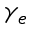<formula> <loc_0><loc_0><loc_500><loc_500>\gamma _ { e }</formula> 